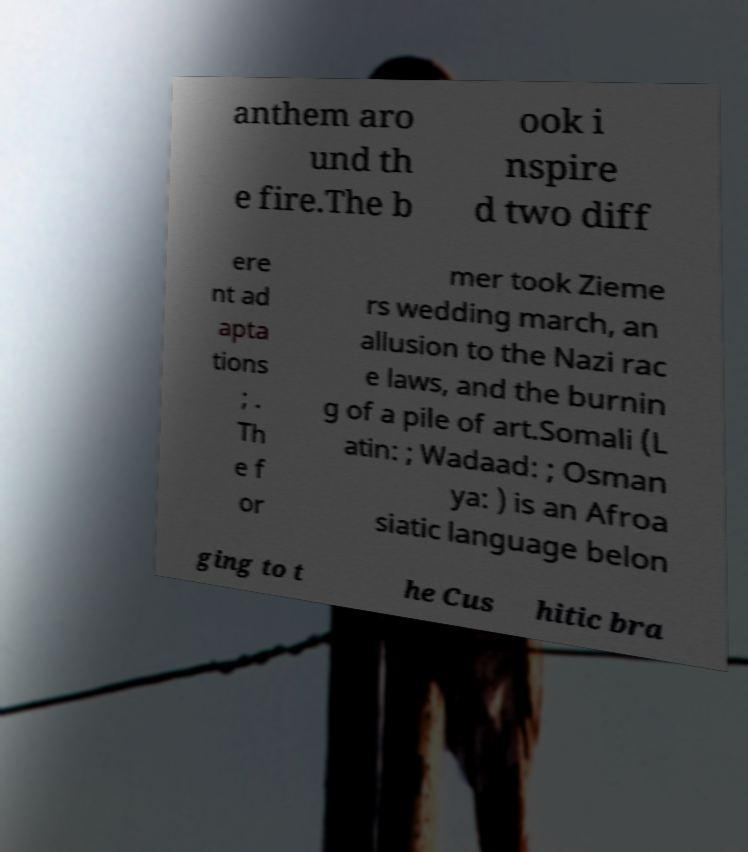Could you extract and type out the text from this image? anthem aro und th e fire.The b ook i nspire d two diff ere nt ad apta tions ; . Th e f or mer took Zieme rs wedding march, an allusion to the Nazi rac e laws, and the burnin g of a pile of art.Somali (L atin: ; Wadaad: ; Osman ya: ) is an Afroa siatic language belon ging to t he Cus hitic bra 